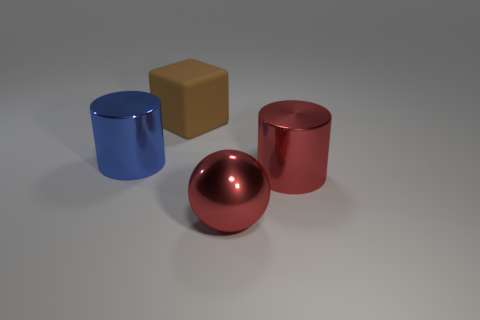Add 4 large gray metal cubes. How many objects exist? 8 Subtract all balls. How many objects are left? 3 Subtract 0 green balls. How many objects are left? 4 Subtract all tiny blue metallic cubes. Subtract all blue metal objects. How many objects are left? 3 Add 3 brown blocks. How many brown blocks are left? 4 Add 3 red balls. How many red balls exist? 4 